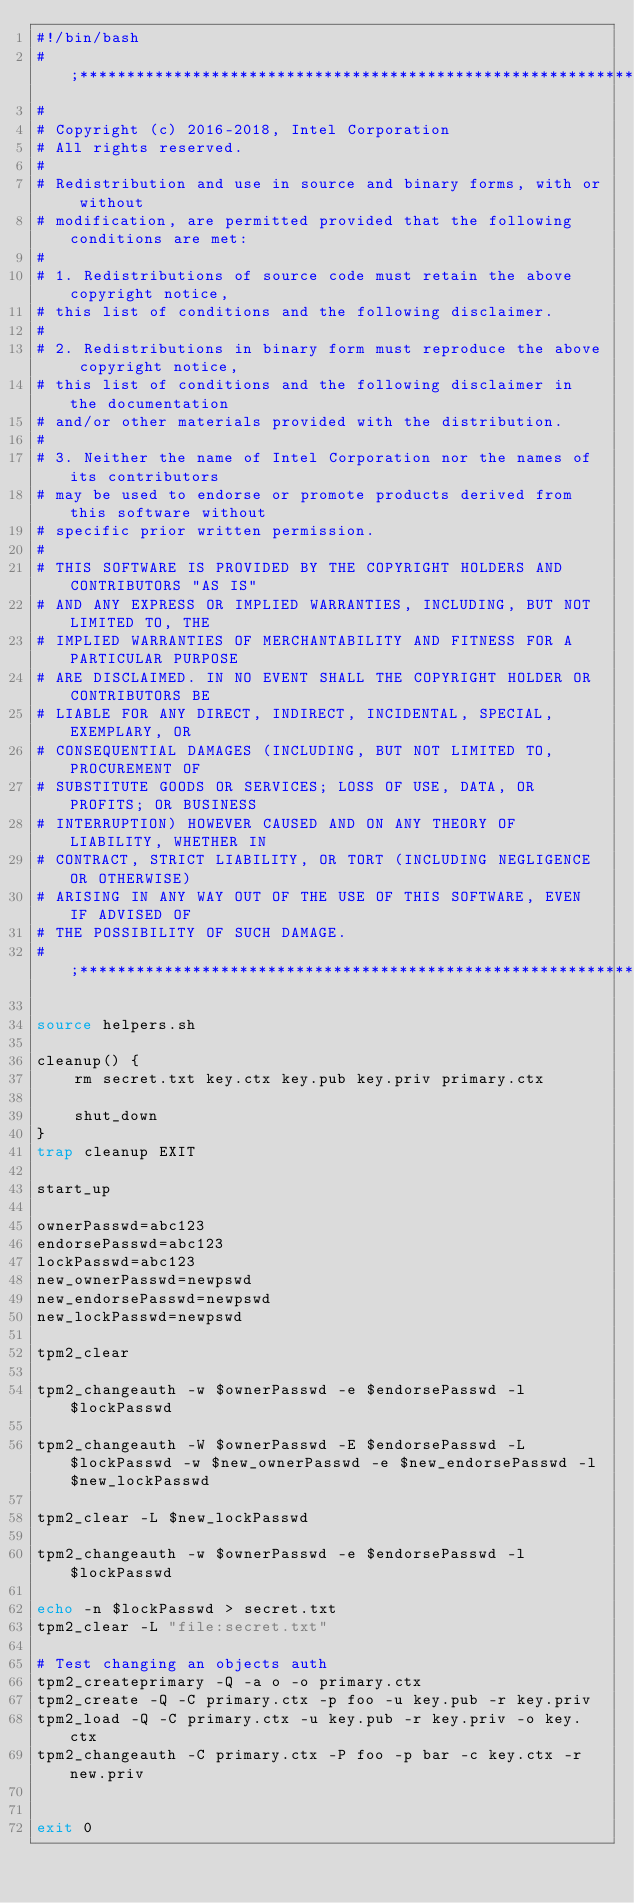<code> <loc_0><loc_0><loc_500><loc_500><_Bash_>#!/bin/bash
#;**********************************************************************;
#
# Copyright (c) 2016-2018, Intel Corporation
# All rights reserved.
#
# Redistribution and use in source and binary forms, with or without
# modification, are permitted provided that the following conditions are met:
#
# 1. Redistributions of source code must retain the above copyright notice,
# this list of conditions and the following disclaimer.
#
# 2. Redistributions in binary form must reproduce the above copyright notice,
# this list of conditions and the following disclaimer in the documentation
# and/or other materials provided with the distribution.
#
# 3. Neither the name of Intel Corporation nor the names of its contributors
# may be used to endorse or promote products derived from this software without
# specific prior written permission.
#
# THIS SOFTWARE IS PROVIDED BY THE COPYRIGHT HOLDERS AND CONTRIBUTORS "AS IS"
# AND ANY EXPRESS OR IMPLIED WARRANTIES, INCLUDING, BUT NOT LIMITED TO, THE
# IMPLIED WARRANTIES OF MERCHANTABILITY AND FITNESS FOR A PARTICULAR PURPOSE
# ARE DISCLAIMED. IN NO EVENT SHALL THE COPYRIGHT HOLDER OR CONTRIBUTORS BE
# LIABLE FOR ANY DIRECT, INDIRECT, INCIDENTAL, SPECIAL, EXEMPLARY, OR
# CONSEQUENTIAL DAMAGES (INCLUDING, BUT NOT LIMITED TO, PROCUREMENT OF
# SUBSTITUTE GOODS OR SERVICES; LOSS OF USE, DATA, OR PROFITS; OR BUSINESS
# INTERRUPTION) HOWEVER CAUSED AND ON ANY THEORY OF LIABILITY, WHETHER IN
# CONTRACT, STRICT LIABILITY, OR TORT (INCLUDING NEGLIGENCE OR OTHERWISE)
# ARISING IN ANY WAY OUT OF THE USE OF THIS SOFTWARE, EVEN IF ADVISED OF
# THE POSSIBILITY OF SUCH DAMAGE.
#;**********************************************************************;

source helpers.sh

cleanup() {
    rm secret.txt key.ctx key.pub key.priv primary.ctx

    shut_down
}
trap cleanup EXIT

start_up

ownerPasswd=abc123
endorsePasswd=abc123
lockPasswd=abc123
new_ownerPasswd=newpswd
new_endorsePasswd=newpswd
new_lockPasswd=newpswd

tpm2_clear

tpm2_changeauth -w $ownerPasswd -e $endorsePasswd -l $lockPasswd

tpm2_changeauth -W $ownerPasswd -E $endorsePasswd -L $lockPasswd -w $new_ownerPasswd -e $new_endorsePasswd -l $new_lockPasswd

tpm2_clear -L $new_lockPasswd

tpm2_changeauth -w $ownerPasswd -e $endorsePasswd -l $lockPasswd

echo -n $lockPasswd > secret.txt
tpm2_clear -L "file:secret.txt"

# Test changing an objects auth
tpm2_createprimary -Q -a o -o primary.ctx
tpm2_create -Q -C primary.ctx -p foo -u key.pub -r key.priv
tpm2_load -Q -C primary.ctx -u key.pub -r key.priv -o key.ctx
tpm2_changeauth -C primary.ctx -P foo -p bar -c key.ctx -r new.priv


exit 0
</code> 